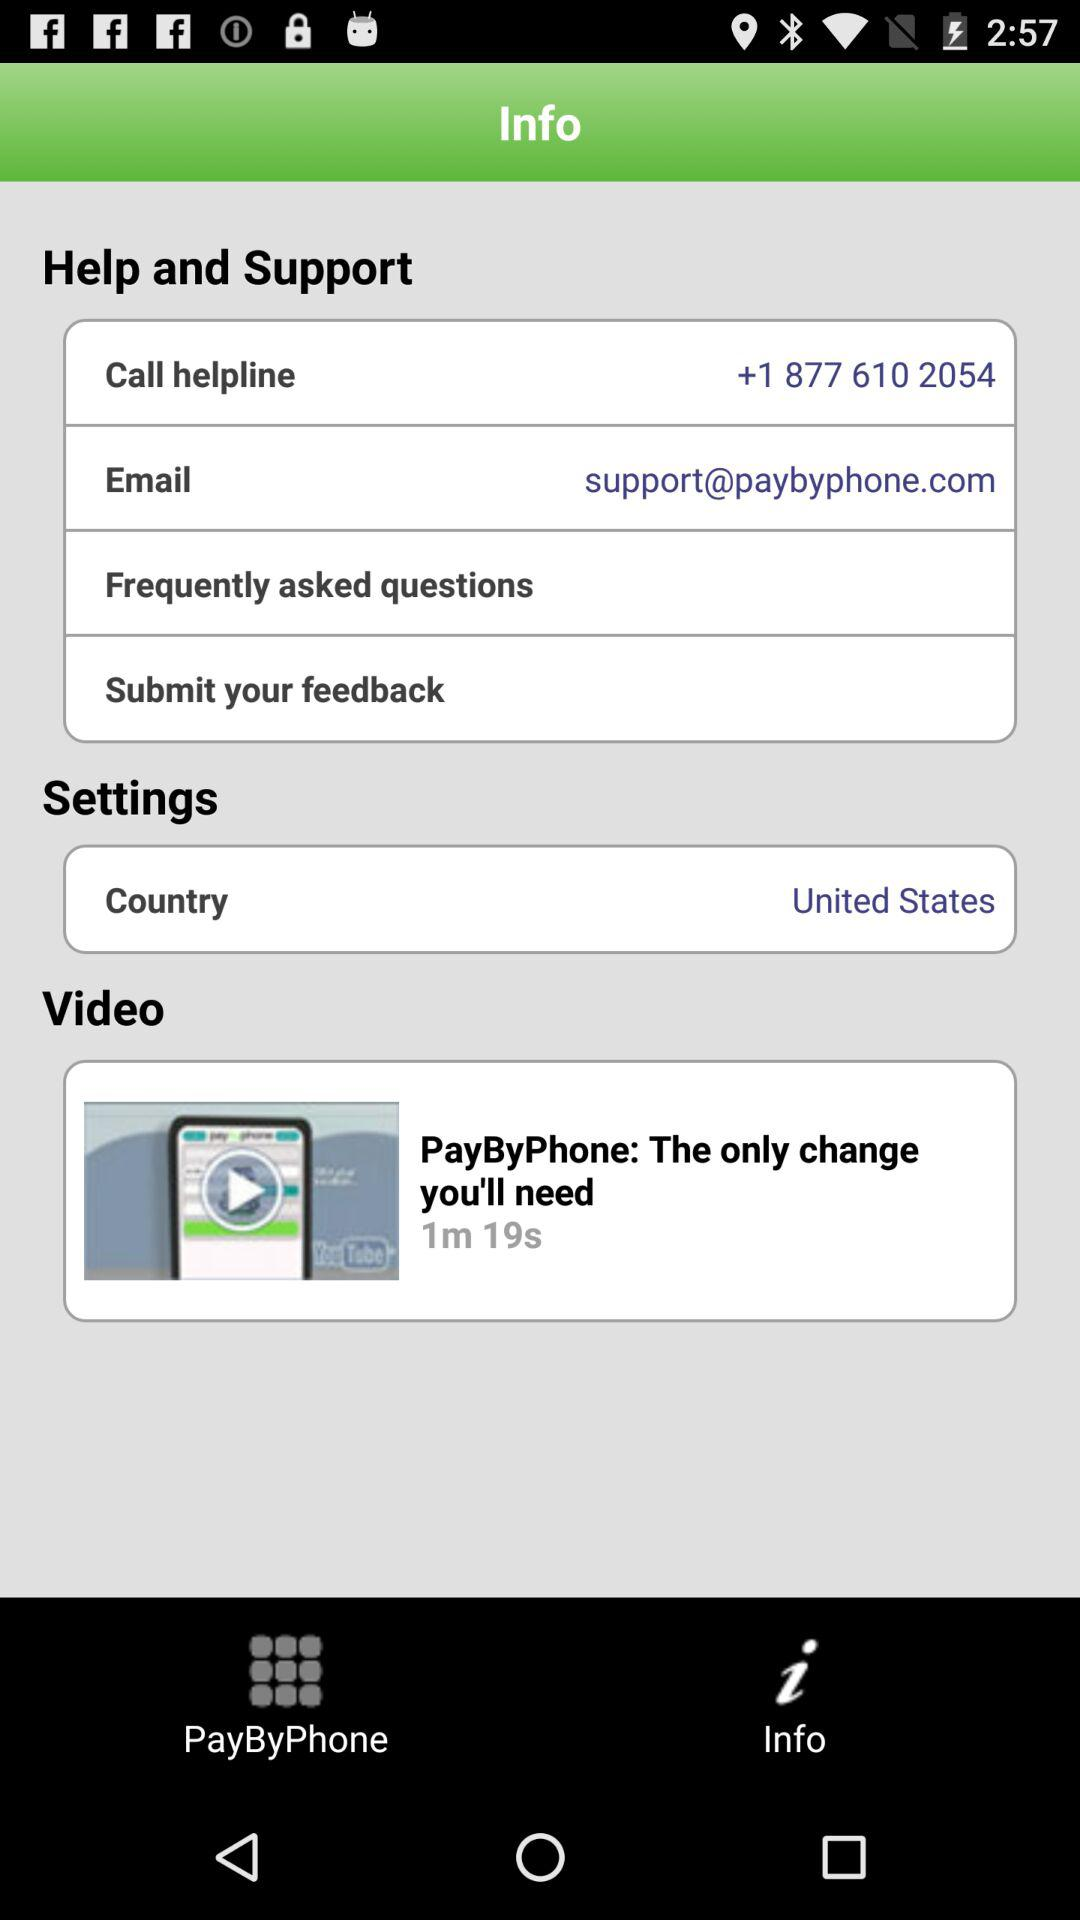What is the contact of helpline? The contact of helpline is +1 877 610 2054. 